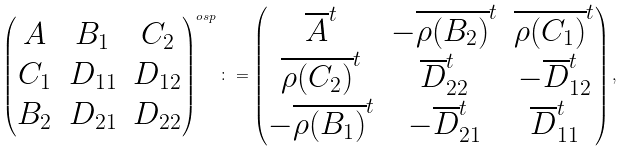Convert formula to latex. <formula><loc_0><loc_0><loc_500><loc_500>\begin{pmatrix} A & B _ { 1 } & C _ { 2 } \\ C _ { 1 } & D _ { 1 1 } & D _ { 1 2 } \\ B _ { 2 } & D _ { 2 1 } & D _ { 2 2 } \end{pmatrix} ^ { o s p } \colon = \begin{pmatrix} \overline { A } ^ { t } & - \overline { \rho ( B _ { 2 } ) } ^ { t } & \overline { \rho ( C _ { 1 } ) } ^ { t } \\ \overline { \rho ( C _ { 2 } ) } ^ { t } & \overline { D } _ { 2 2 } ^ { t } & - \overline { D } _ { 1 2 } ^ { t } \\ - \overline { \rho ( B _ { 1 } ) } ^ { t } & - \overline { D } _ { 2 1 } ^ { t } & \overline { D } _ { 1 1 } ^ { t } \end{pmatrix} ,</formula> 